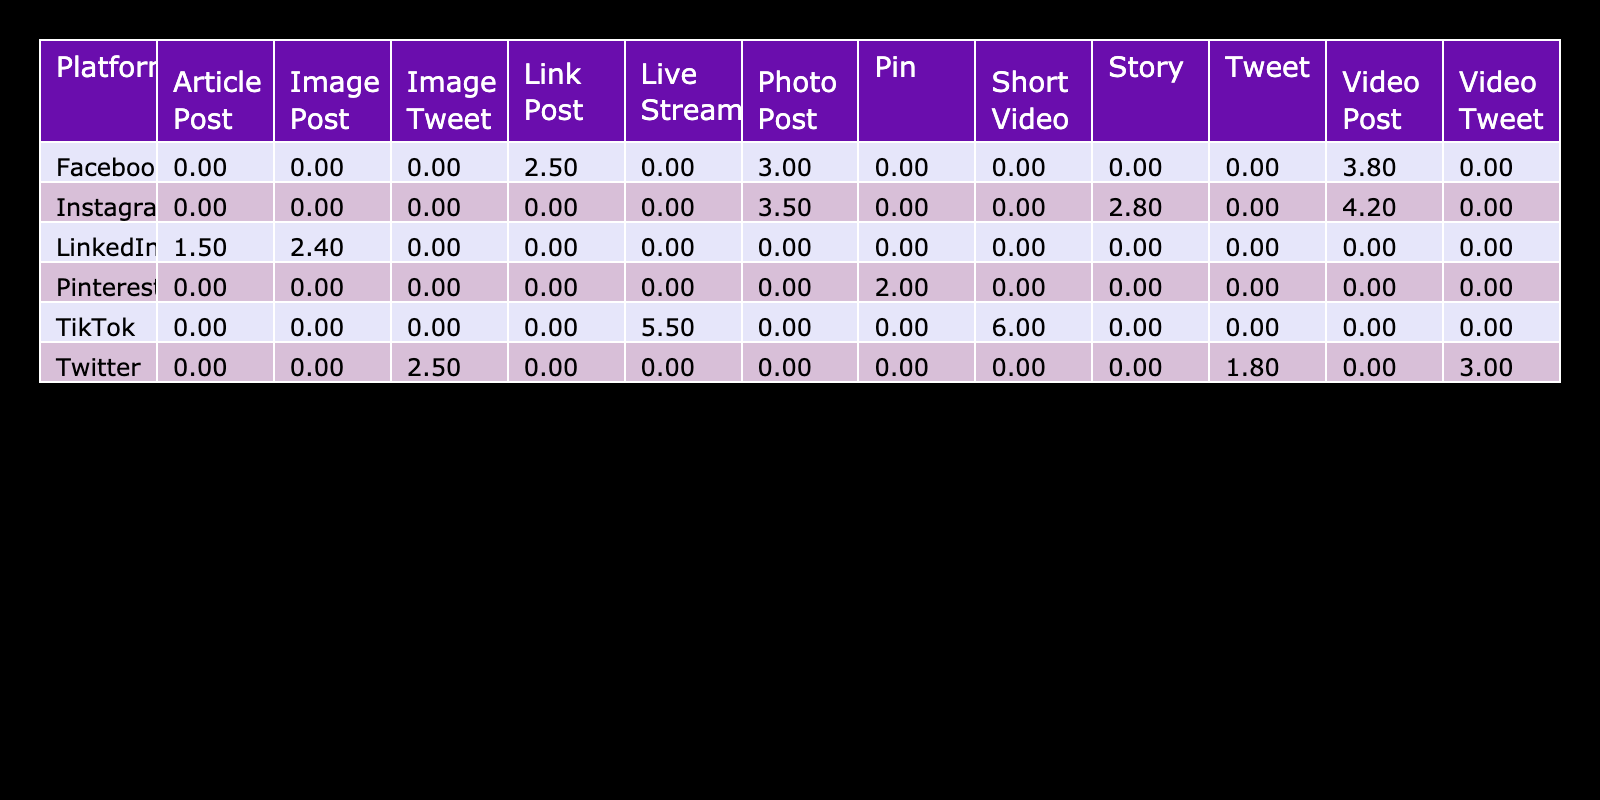What is the engagement rate for TikTok's Short Video post type? The table shows the engagement rate for each post type on TikTok. Looking under the TikTok row and the Short Video column, the engagement rate is listed as 6.0%.
Answer: 6.0% Which platform has the highest average likes for video posts? To find this, we look at the average likes column specifically for video posts across all platforms. For TikTok's Short Video, the likes are 2000, which is the highest compared to others.
Answer: TikTok What is the average engagement rate for Instagram post types? To calculate the average engagement rate for Instagram, we take the engagement rates of all Instagram post types: Photo Post (3.5%), Video Post (4.2%), and Story (2.8%). The sum is 3.5 + 4.2 + 2.8 = 10.5%. We then divide by 3 (the number of post types), resulting in an average of 10.5/3 = 3.5%.
Answer: 3.5% Is the average comments for Facebook Video Post greater than 30? The average comments for Facebook Video Post is 35 according to the table. Since 35 is greater than 30, the statement is true.
Answer: Yes Which post type across all platforms has the lowest engagement rate? By scanning down the engagement rate column for each post type, we identify that the Pin post type on Pinterest has an engagement rate of 2.0%, which is the lowest among all listed post types.
Answer: Pin What is the difference in average shares between TikTok's Live Stream and Instagram's Video Post? First, we find the average shares for TikTok's Live Stream, which is 400. Then, we find Instagram's Video Post, which has average shares of 300. The difference is calculated as 400 - 300 = 100.
Answer: 100 Are there any platforms where the engagement rate for photo posts exceeds 3%? Checking the engagement rates for photo posts, we see that Instagram has 3.5% and Facebook has 3.0%. Only Instagram exceeds 3%, making the statement true.
Answer: Yes What is the average number of comments for Twitter post types? To compute the average number of comments, we look at the average comments for Tweet (10), Image Tweet (20), and Video Tweet (25). Their total is 10 + 20 + 25 = 55. Dividing by 3 gives us an average of 55/3 = 18.33.
Answer: 18.33 Which post type has the second highest average engagement rate? After reviewing the engagement rates, the highest is TikTok's Short Video (6.0%), followed by TikTok's Live Stream (5.5%). Thus, Live Stream is the second highest.
Answer: Live Stream What are the average likes for Facebook Photo Post and Twitter Image Tweet combined? The average likes for Facebook Photo Post is 500, while for Twitter Image Tweet it is 350. Adding these together gives 500 + 350 = 850 likes.
Answer: 850 